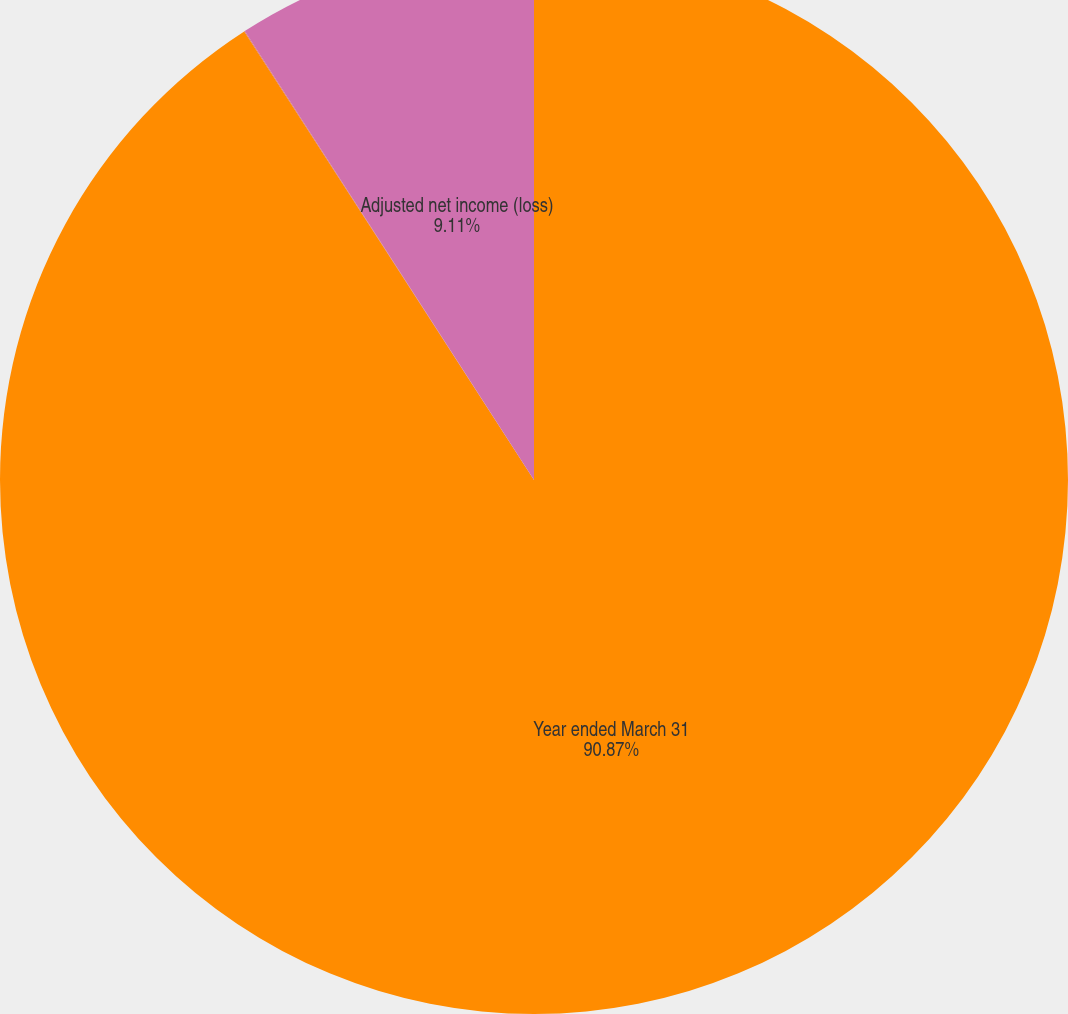Convert chart. <chart><loc_0><loc_0><loc_500><loc_500><pie_chart><fcel>Year ended March 31<fcel>Reported net income (loss)<fcel>Adjusted net income (loss)<nl><fcel>90.87%<fcel>0.02%<fcel>9.11%<nl></chart> 